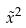<formula> <loc_0><loc_0><loc_500><loc_500>\tilde { x } ^ { 2 }</formula> 